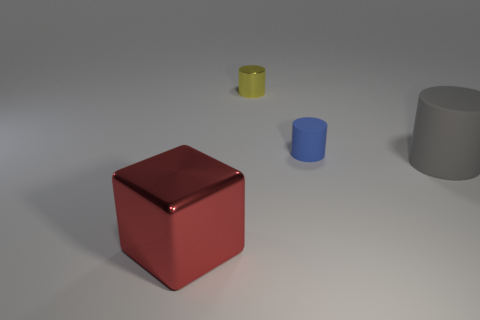Can you describe the shapes of the objects in the image? Certainly! The image features a variety of geometric shapes: there's a large red cube, a medium-sized yellow cylinder, a small blue cylinder, and a large grey cylinder with open ends, often referred to as a hollow cylinder or tube. 